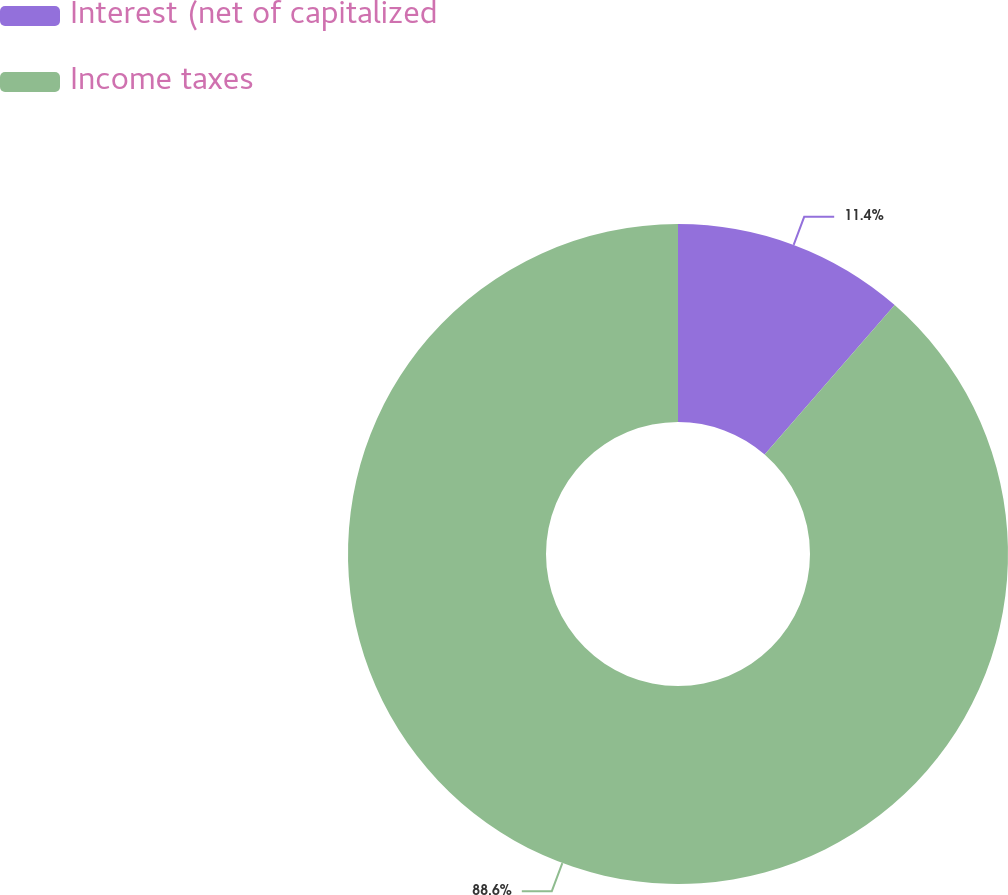Convert chart. <chart><loc_0><loc_0><loc_500><loc_500><pie_chart><fcel>Interest (net of capitalized<fcel>Income taxes<nl><fcel>11.4%<fcel>88.6%<nl></chart> 